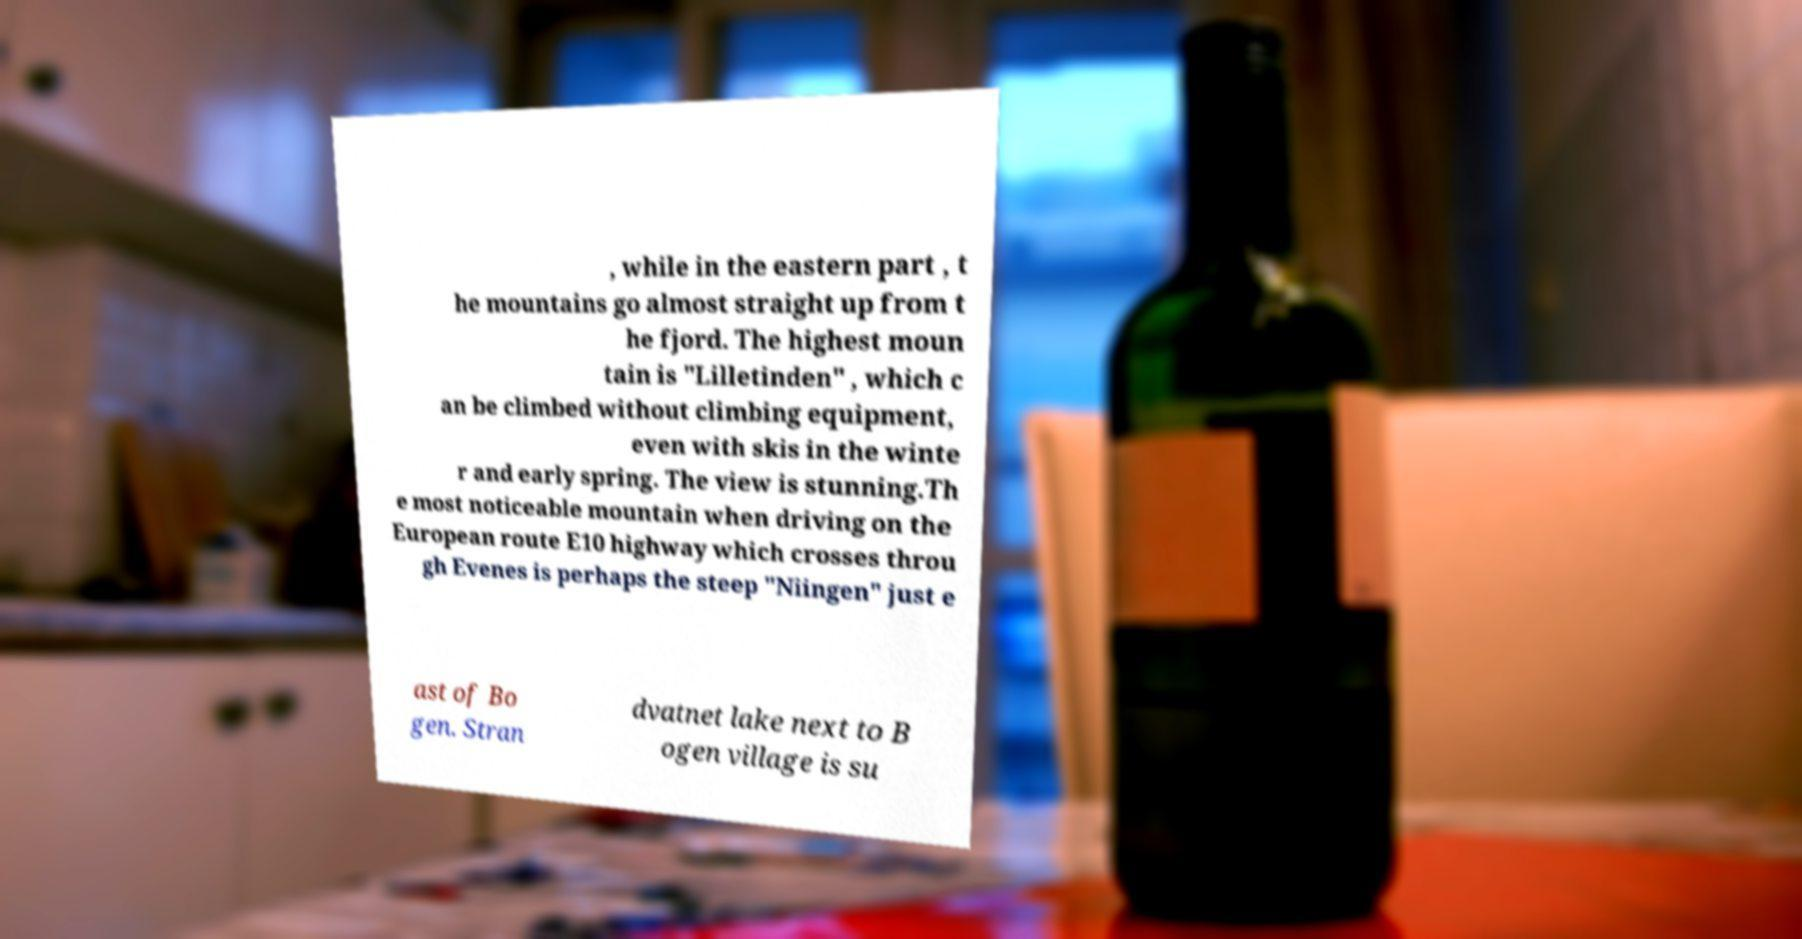Could you assist in decoding the text presented in this image and type it out clearly? , while in the eastern part , t he mountains go almost straight up from t he fjord. The highest moun tain is "Lilletinden" , which c an be climbed without climbing equipment, even with skis in the winte r and early spring. The view is stunning.Th e most noticeable mountain when driving on the European route E10 highway which crosses throu gh Evenes is perhaps the steep "Niingen" just e ast of Bo gen. Stran dvatnet lake next to B ogen village is su 